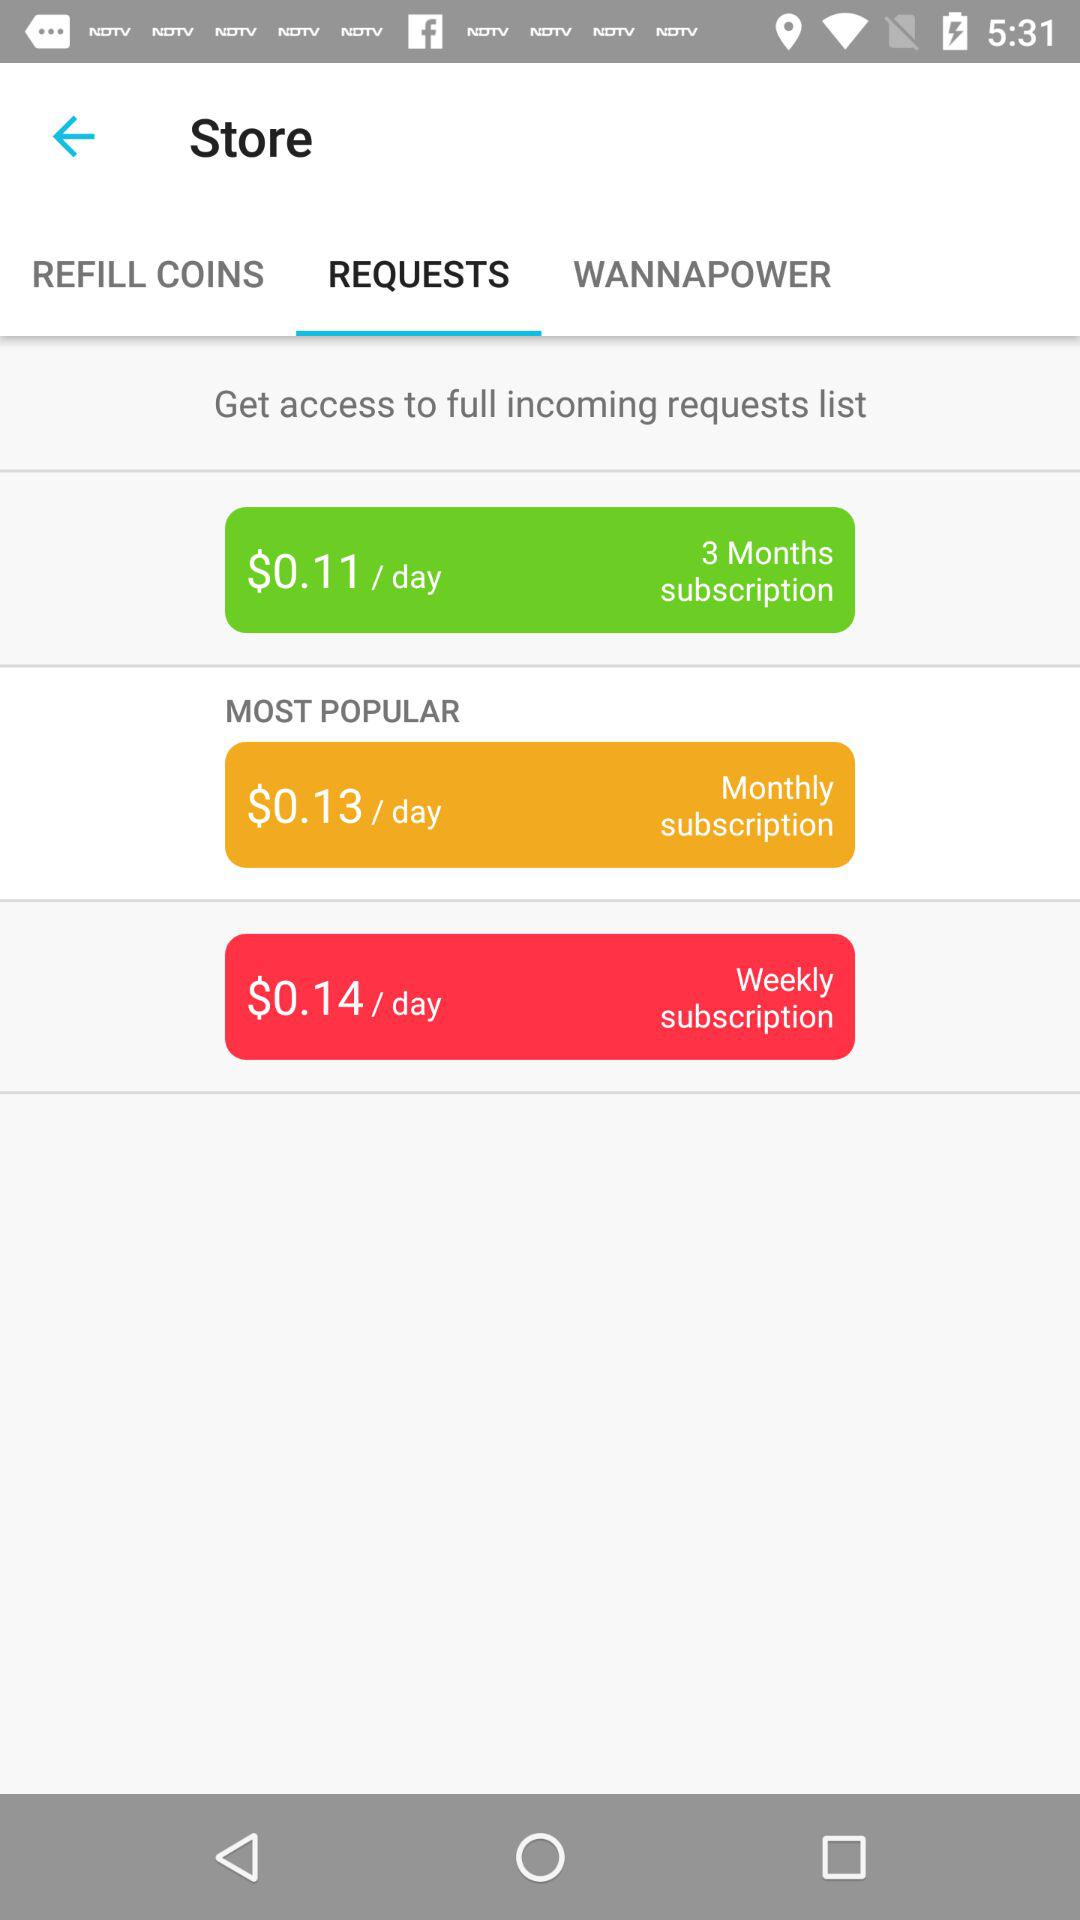What is the per-day cost for a three-month subscription? The per-day cost for a three-month subscription is $0.11. 